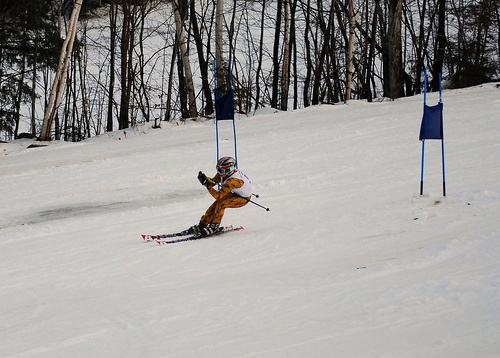Describe the objects in this image and their specific colors. I can see people in black, maroon, brown, and gray tones and skis in black, gray, darkgray, and lightgray tones in this image. 